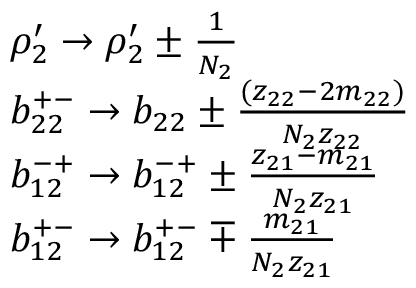Convert formula to latex. <formula><loc_0><loc_0><loc_500><loc_500>\begin{array} { r l } & { \rho _ { 2 } ^ { \prime } \rightarrow \rho _ { 2 } ^ { \prime } \pm \frac { 1 } { N _ { 2 } } } \\ & { b _ { 2 2 } ^ { + - } \rightarrow b _ { 2 2 } \pm \frac { ( z _ { 2 2 } - 2 m _ { 2 2 } ) } { N _ { 2 } z _ { 2 2 } } } \\ & { b _ { 1 2 } ^ { - + } \rightarrow b _ { 1 2 } ^ { - + } \pm \frac { z _ { 2 1 } - m _ { 2 1 } } { N _ { 2 } z _ { 2 1 } } } \\ & { b _ { 1 2 } ^ { + - } \rightarrow b _ { 1 2 } ^ { + - } \mp \frac { m _ { 2 1 } } { N _ { 2 } z _ { 2 1 } } } \end{array}</formula> 